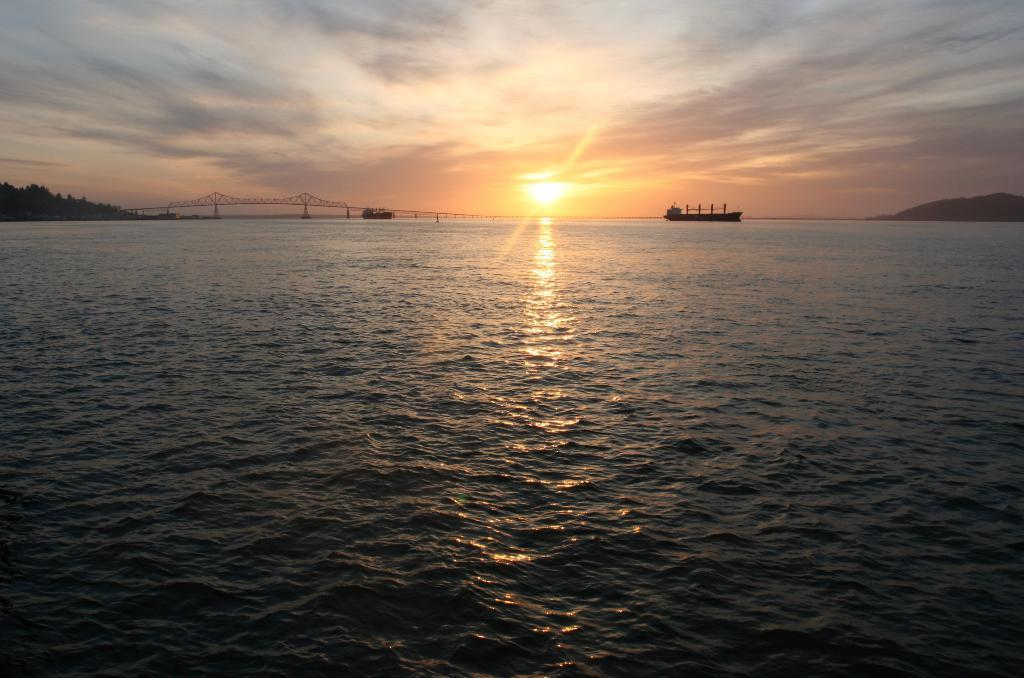What type of vehicles can be seen in the water in the image? There are boats in the water in the image. What type of structure is present in the image? There is a bridge in the image. What type of natural elements can be seen in the image? There are trees and a hill in the image. What is visible in the sky in the image? The sky and the sun are visible in the image. Where is the jail located in the image? There is no jail present in the image. Can you tell me how many sinks are visible in the image? There are no sinks present in the image. 